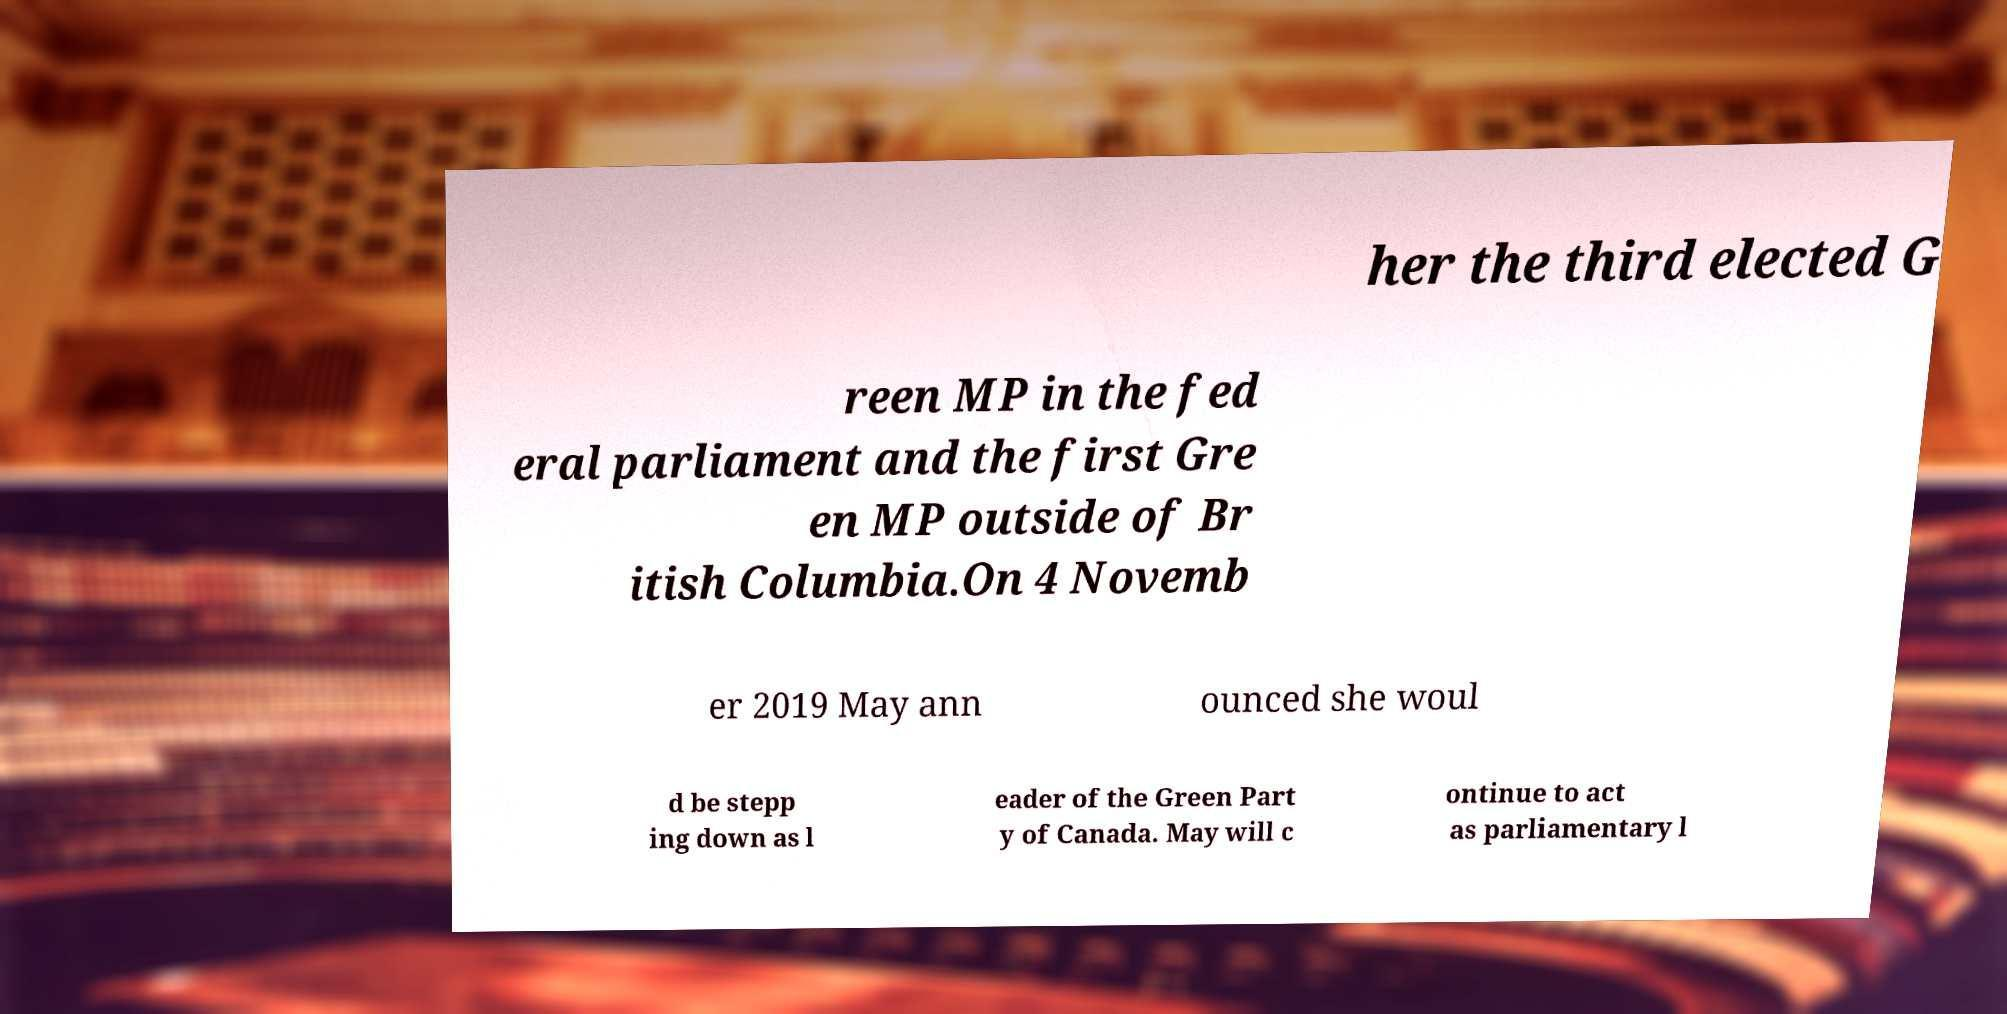Could you assist in decoding the text presented in this image and type it out clearly? her the third elected G reen MP in the fed eral parliament and the first Gre en MP outside of Br itish Columbia.On 4 Novemb er 2019 May ann ounced she woul d be stepp ing down as l eader of the Green Part y of Canada. May will c ontinue to act as parliamentary l 